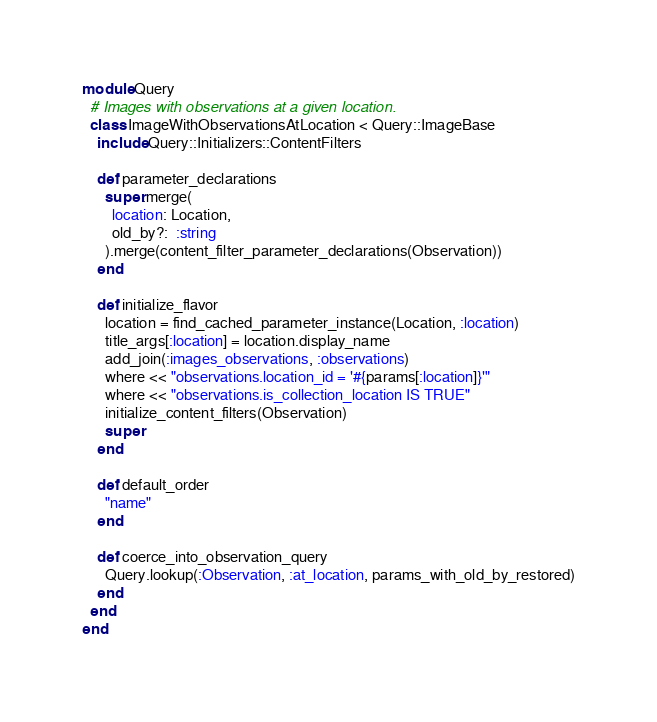<code> <loc_0><loc_0><loc_500><loc_500><_Ruby_>module Query
  # Images with observations at a given location.
  class ImageWithObservationsAtLocation < Query::ImageBase
    include Query::Initializers::ContentFilters

    def parameter_declarations
      super.merge(
        location: Location,
        old_by?:  :string
      ).merge(content_filter_parameter_declarations(Observation))
    end

    def initialize_flavor
      location = find_cached_parameter_instance(Location, :location)
      title_args[:location] = location.display_name
      add_join(:images_observations, :observations)
      where << "observations.location_id = '#{params[:location]}'"
      where << "observations.is_collection_location IS TRUE"
      initialize_content_filters(Observation)
      super
    end

    def default_order
      "name"
    end

    def coerce_into_observation_query
      Query.lookup(:Observation, :at_location, params_with_old_by_restored)
    end
  end
end
</code> 